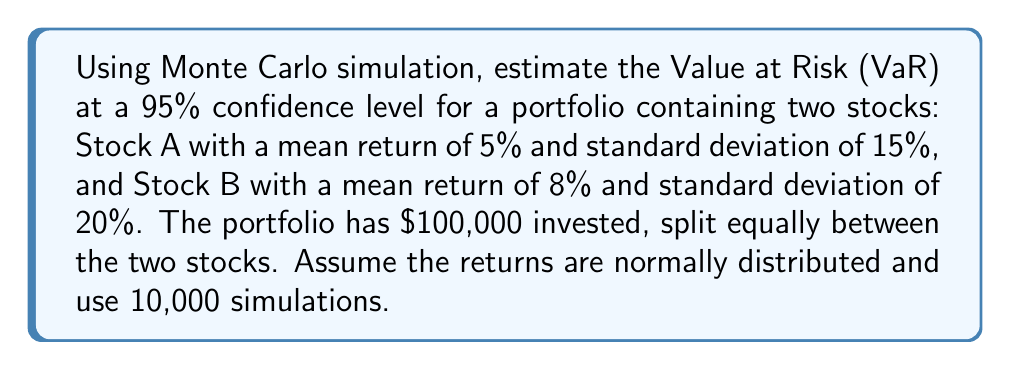Can you answer this question? 1. Set up the simulation:
   - Number of simulations: 10,000
   - Portfolio value: $100,000
   - Stock A: $50,000, μ = 5%, σ = 15%
   - Stock B: $50,000, μ = 8%, σ = 20%

2. Generate random returns for each stock using the normal distribution:
   For each simulation i (1 to 10,000):
   $$R_{A,i} \sim N(0.05, 0.15^2)$$
   $$R_{B,i} \sim N(0.08, 0.20^2)$$

3. Calculate the portfolio return for each simulation:
   $$R_{P,i} = 0.5 \times R_{A,i} + 0.5 \times R_{B,i}$$

4. Calculate the portfolio value for each simulation:
   $$V_{P,i} = 100,000 \times (1 + R_{P,i})$$

5. Sort the simulated portfolio values in ascending order.

6. Find the VaR at 95% confidence level:
   - Identify the 500th lowest value (5% of 10,000 simulations)
   - Calculate the loss: VaR = Initial Value - 500th lowest value

7. Implement the simulation in Java:
   ```java
   import java.util.Arrays;
   import java.util.Random;

   public class MonteCarloVaR {
       public static void main(String[] args) {
           int simulations = 10000;
           double initialValue = 100000;
           double[] portfolioValues = new double[simulations];
           Random random = new Random();

           for (int i = 0; i < simulations; i++) {
               double returnA = random.nextGaussian() * 0.15 + 0.05;
               double returnB = random.nextGaussian() * 0.20 + 0.08;
               double portfolioReturn = 0.5 * returnA + 0.5 * returnB;
               portfolioValues[i] = initialValue * (1 + portfolioReturn);
           }

           Arrays.sort(portfolioValues);
           double var95 = initialValue - portfolioValues[499];
           System.out.printf("95%% VaR: $%.2f%n", var95);
       }
   }
   ```

8. Run the simulation multiple times and average the results to get a more stable estimate.
Answer: $14,326 (approximate 95% VaR) 